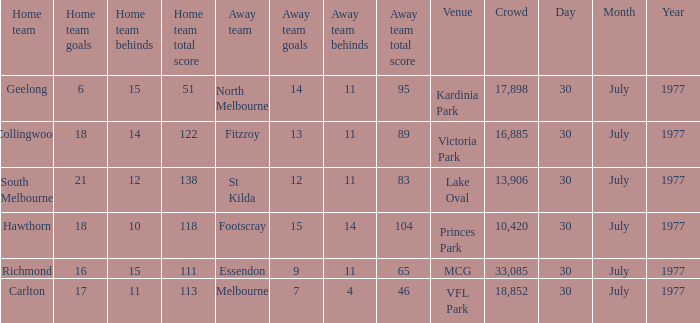Parse the table in full. {'header': ['Home team', 'Home team goals', 'Home team behinds', 'Home team total score', 'Away team', 'Away team goals', 'Away team behinds', 'Away team total score', 'Venue', 'Crowd', 'Day', 'Month', 'Year'], 'rows': [['Geelong', '6', '15', '51', 'North Melbourne', '14', '11', '95', 'Kardinia Park', '17,898', '30', 'July', '1977'], ['Collingwood', '18', '14', '122', 'Fitzroy', '13', '11', '89', 'Victoria Park', '16,885', '30', 'July', '1977'], ['South Melbourne', '21', '12', '138', 'St Kilda', '12', '11', '83', 'Lake Oval', '13,906', '30', 'July', '1977'], ['Hawthorn', '18', '10', '118', 'Footscray', '15', '14', '104', 'Princes Park', '10,420', '30', 'July', '1977'], ['Richmond', '16', '15', '111', 'Essendon', '9', '11', '65', 'MCG', '33,085', '30', 'July', '1977'], ['Carlton', '17', '11', '113', 'Melbourne', '7', '4', '46', 'VFL Park', '18,852', '30', 'July', '1977']]} What is north melbourne's score as a guest side? 14.11 (95). 